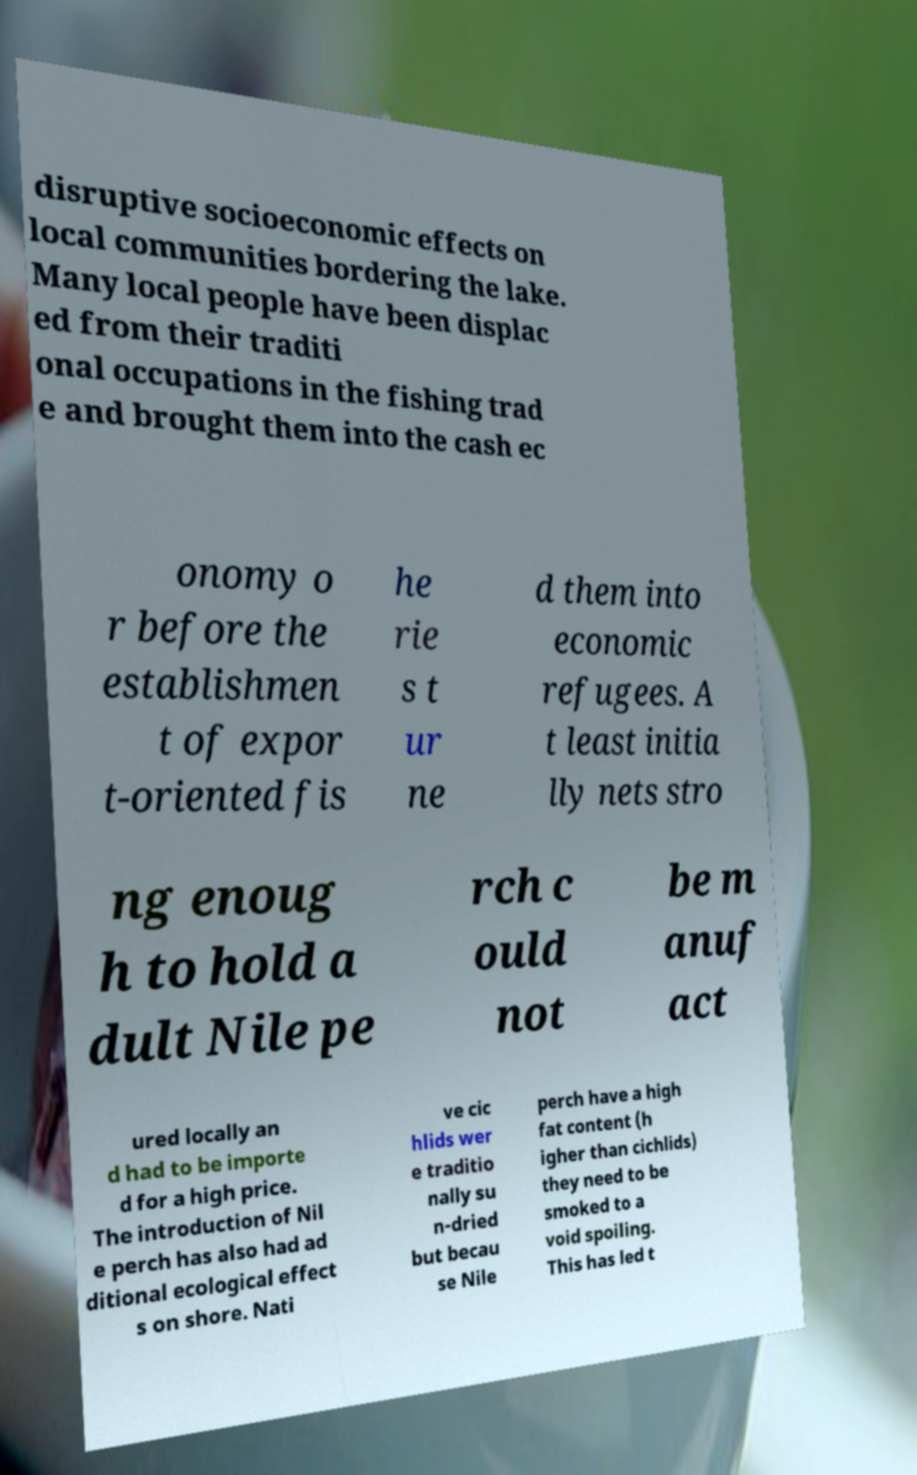Can you accurately transcribe the text from the provided image for me? disruptive socioeconomic effects on local communities bordering the lake. Many local people have been displac ed from their traditi onal occupations in the fishing trad e and brought them into the cash ec onomy o r before the establishmen t of expor t-oriented fis he rie s t ur ne d them into economic refugees. A t least initia lly nets stro ng enoug h to hold a dult Nile pe rch c ould not be m anuf act ured locally an d had to be importe d for a high price. The introduction of Nil e perch has also had ad ditional ecological effect s on shore. Nati ve cic hlids wer e traditio nally su n-dried but becau se Nile perch have a high fat content (h igher than cichlids) they need to be smoked to a void spoiling. This has led t 